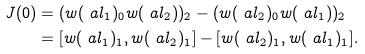Convert formula to latex. <formula><loc_0><loc_0><loc_500><loc_500>J ( 0 ) & = ( w ( \ a l _ { 1 } ) _ { 0 } w ( \ a l _ { 2 } ) ) _ { 2 } - ( w ( \ a l _ { 2 } ) _ { 0 } w ( \ a l _ { 1 } ) ) _ { 2 } \\ & = [ w ( \ a l _ { 1 } ) _ { 1 } , w ( \ a l _ { 2 } ) _ { 1 } ] - [ w ( \ a l _ { 2 } ) _ { 1 } , w ( \ a l _ { 1 } ) _ { 1 } ] .</formula> 